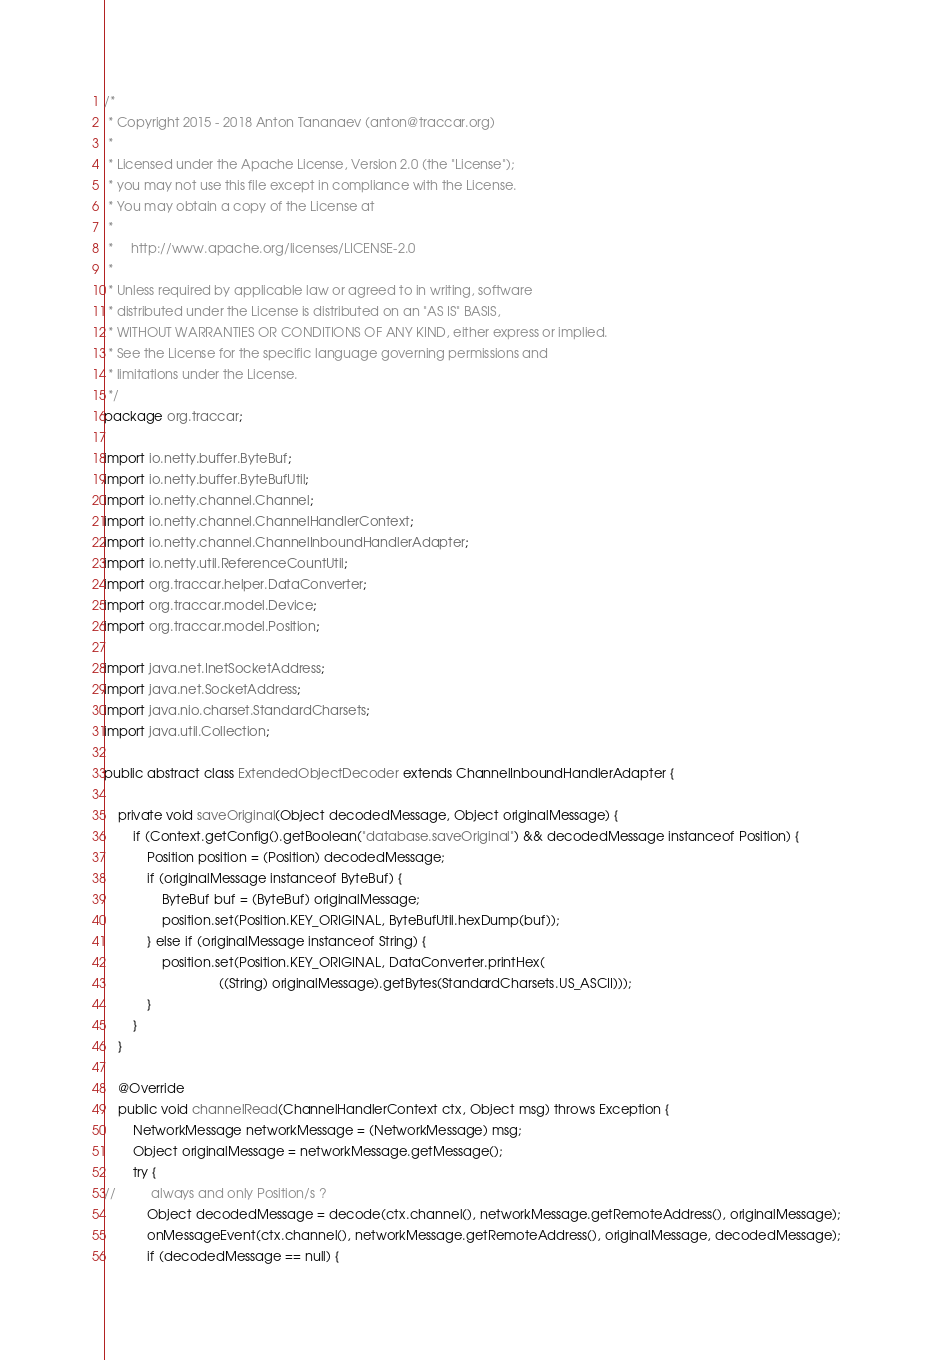<code> <loc_0><loc_0><loc_500><loc_500><_Java_>/*
 * Copyright 2015 - 2018 Anton Tananaev (anton@traccar.org)
 *
 * Licensed under the Apache License, Version 2.0 (the "License");
 * you may not use this file except in compliance with the License.
 * You may obtain a copy of the License at
 *
 *     http://www.apache.org/licenses/LICENSE-2.0
 *
 * Unless required by applicable law or agreed to in writing, software
 * distributed under the License is distributed on an "AS IS" BASIS,
 * WITHOUT WARRANTIES OR CONDITIONS OF ANY KIND, either express or implied.
 * See the License for the specific language governing permissions and
 * limitations under the License.
 */
package org.traccar;

import io.netty.buffer.ByteBuf;
import io.netty.buffer.ByteBufUtil;
import io.netty.channel.Channel;
import io.netty.channel.ChannelHandlerContext;
import io.netty.channel.ChannelInboundHandlerAdapter;
import io.netty.util.ReferenceCountUtil;
import org.traccar.helper.DataConverter;
import org.traccar.model.Device;
import org.traccar.model.Position;

import java.net.InetSocketAddress;
import java.net.SocketAddress;
import java.nio.charset.StandardCharsets;
import java.util.Collection;

public abstract class ExtendedObjectDecoder extends ChannelInboundHandlerAdapter {

    private void saveOriginal(Object decodedMessage, Object originalMessage) {
        if (Context.getConfig().getBoolean("database.saveOriginal") && decodedMessage instanceof Position) {
            Position position = (Position) decodedMessage;
            if (originalMessage instanceof ByteBuf) {
                ByteBuf buf = (ByteBuf) originalMessage;
                position.set(Position.KEY_ORIGINAL, ByteBufUtil.hexDump(buf));
            } else if (originalMessage instanceof String) {
                position.set(Position.KEY_ORIGINAL, DataConverter.printHex(
                                ((String) originalMessage).getBytes(StandardCharsets.US_ASCII)));
            }
        }
    }

    @Override
    public void channelRead(ChannelHandlerContext ctx, Object msg) throws Exception {
        NetworkMessage networkMessage = (NetworkMessage) msg;
        Object originalMessage = networkMessage.getMessage();
        try {
//          always and only Position/s ?
            Object decodedMessage = decode(ctx.channel(), networkMessage.getRemoteAddress(), originalMessage);
            onMessageEvent(ctx.channel(), networkMessage.getRemoteAddress(), originalMessage, decodedMessage);
            if (decodedMessage == null) {</code> 